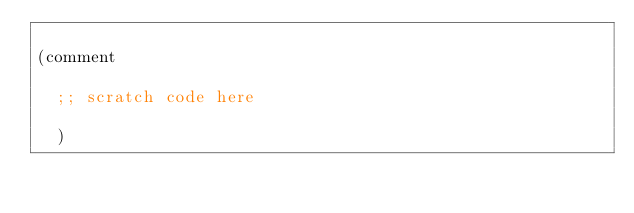Convert code to text. <code><loc_0><loc_0><loc_500><loc_500><_Clojure_>
(comment

  ;; scratch code here

  )
</code> 